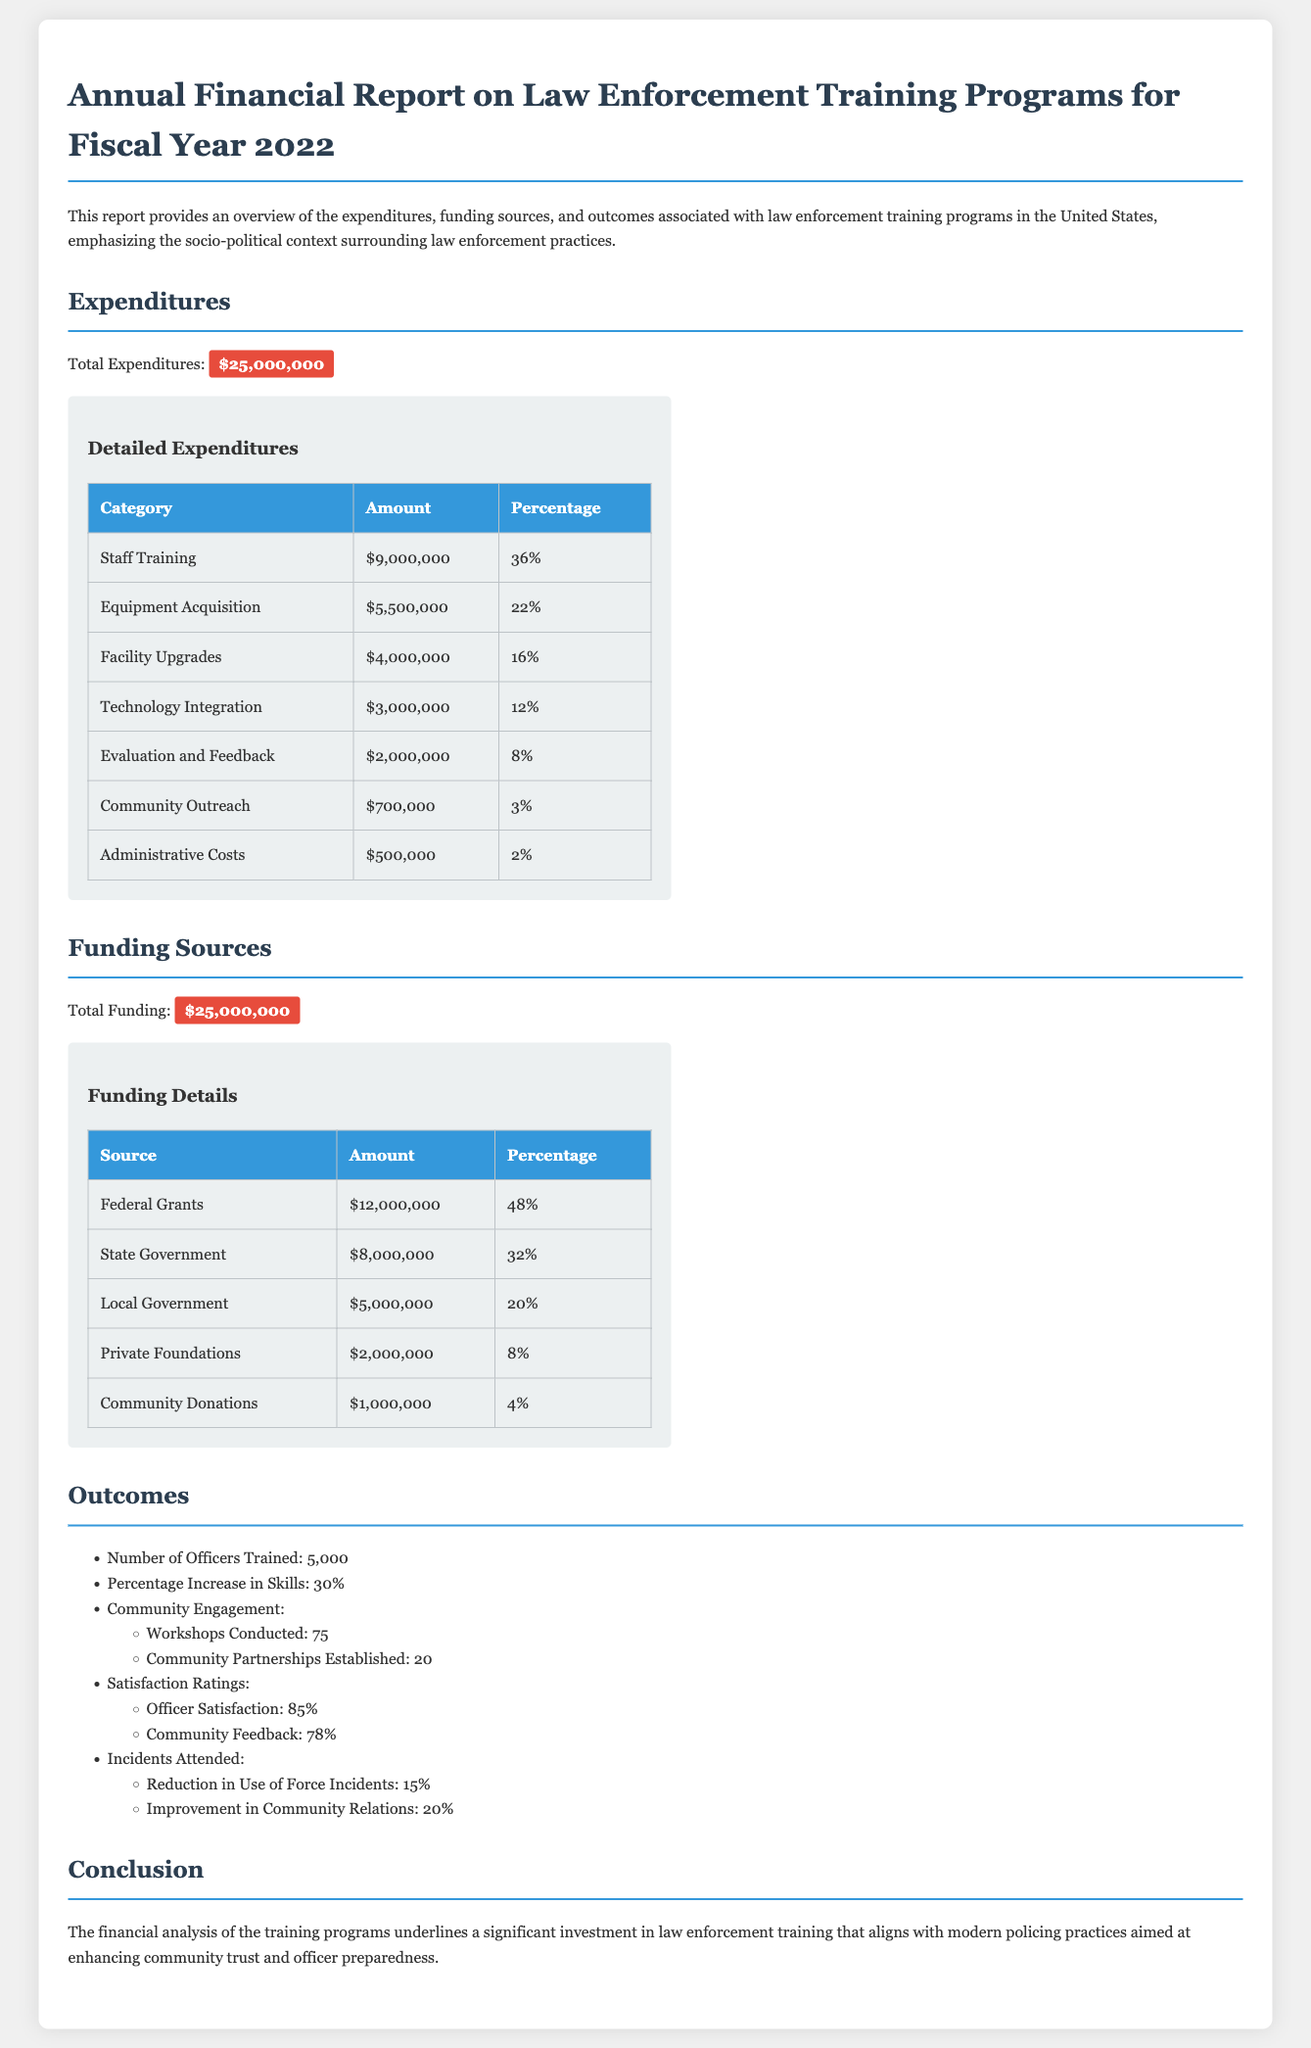What is the total expenditure for the training programs? The total expenditure is the amount specified in the expenditures section of the document, which is $25,000,000.
Answer: $25,000,000 What percentage of expenditures was allocated to Staff Training? The percentage of expenditures allocated to Staff Training can be found in the detailed expenditures table, which shows 36%.
Answer: 36% How many officers were trained in the program? The number of officers trained is listed in the outcomes section, which states 5,000 officers were trained.
Answer: 5,000 What is the total funding for the training programs? The total funding amount is provided in the funding sources section, which is $25,000,000.
Answer: $25,000,000 What was the increase in skills percentage reported? The percentage increase in skills can be found in the outcomes section, which states 30% increase in skills.
Answer: 30% Which funding source contributed the most amount? The funding source with the highest contribution is detailed in the funding sources table, indicating Federal Grants as the top source with $12,000,000.
Answer: Federal Grants How many community partnerships were established as an outcome? The number of community partnerships established is included in the outcomes section, stating there were 20 partnerships.
Answer: 20 What was the officer satisfaction rating? The officer satisfaction rating is provided in the outcomes section, which indicates an 85% satisfaction rating.
Answer: 85% What is the conclusion of the financial report? The conclusion summarizes the analysis, focusing on modern policing practices enhancing community trust and officer preparedness.
Answer: Enhancing community trust and officer preparedness 